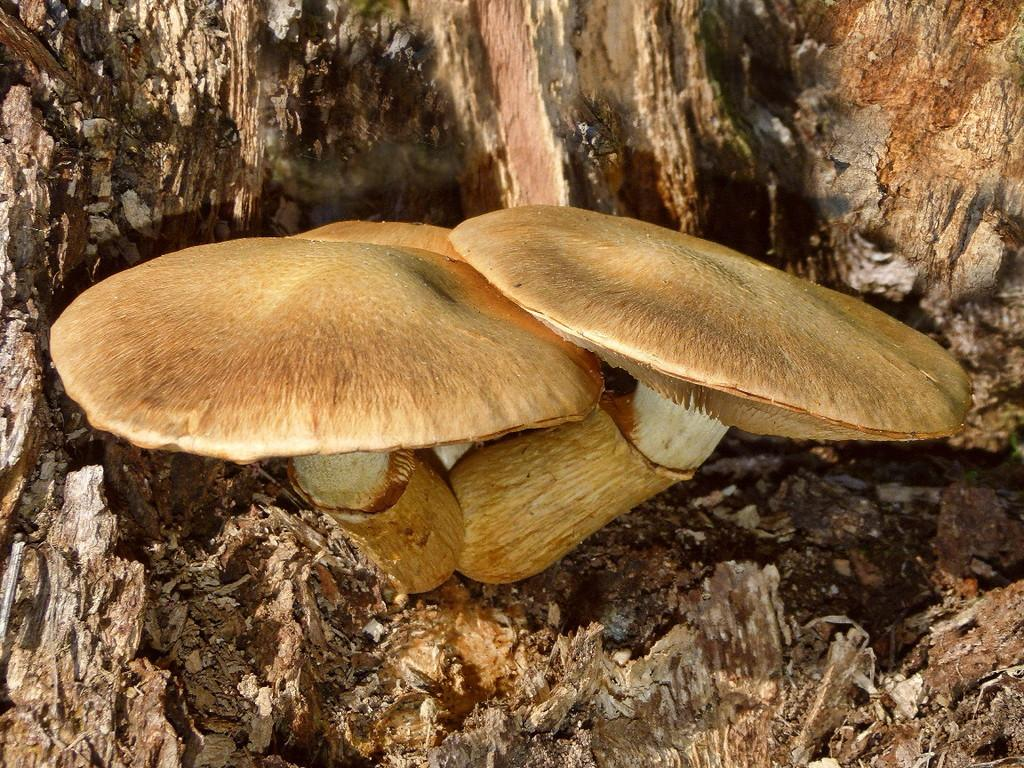What type of fungi can be seen in the image? There are two mushrooms in the image. Where are the mushrooms located? The mushrooms are grown upon a tree. What type of bun is being used to cook the mushrooms in the image? There is no bun present in the image, and the mushrooms are not being cooked. 